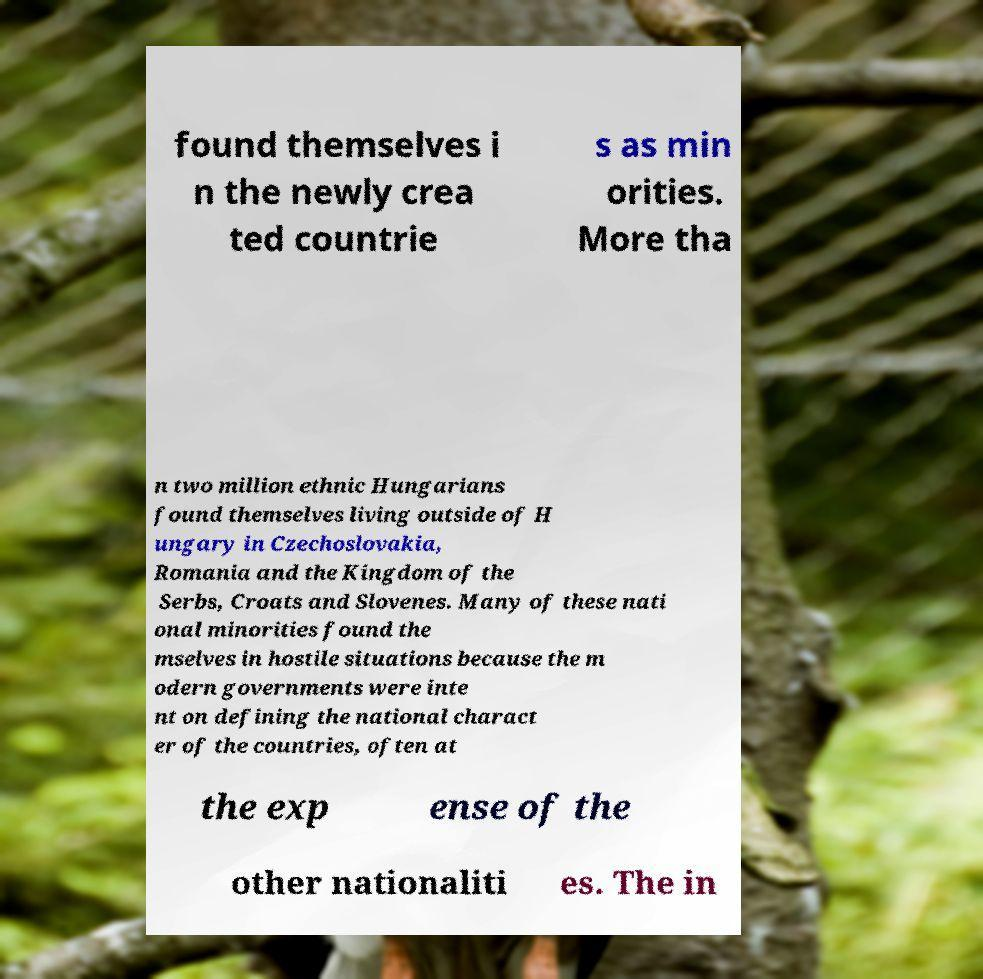Please read and relay the text visible in this image. What does it say? found themselves i n the newly crea ted countrie s as min orities. More tha n two million ethnic Hungarians found themselves living outside of H ungary in Czechoslovakia, Romania and the Kingdom of the Serbs, Croats and Slovenes. Many of these nati onal minorities found the mselves in hostile situations because the m odern governments were inte nt on defining the national charact er of the countries, often at the exp ense of the other nationaliti es. The in 